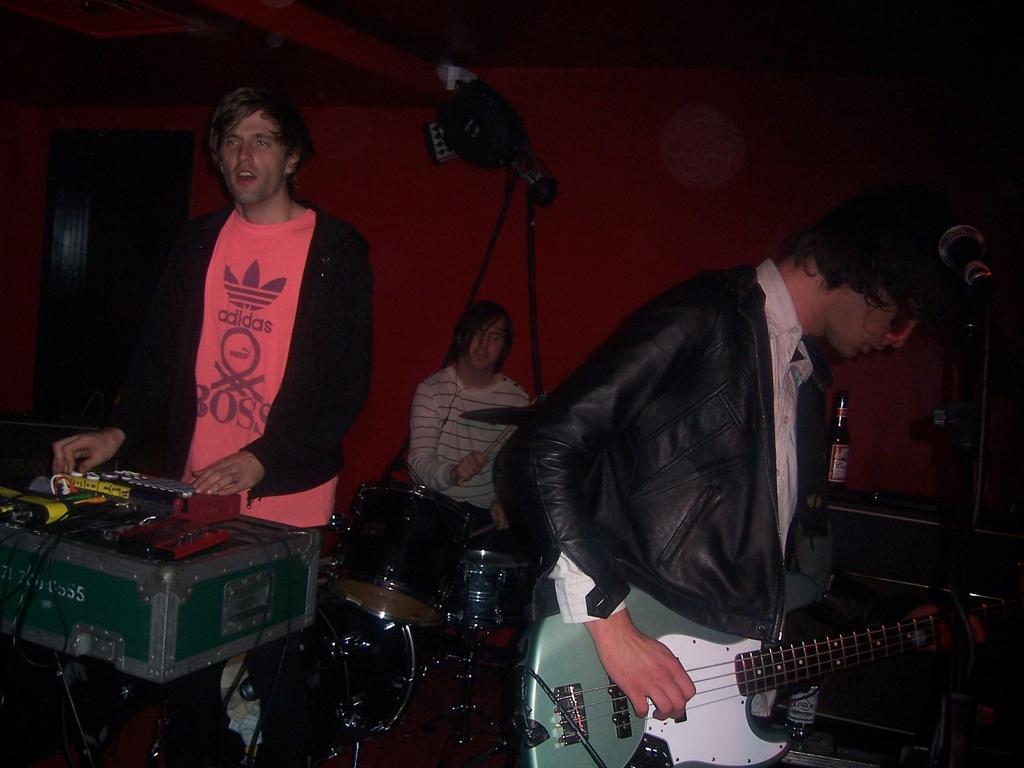How would you summarize this image in a sentence or two? In this image there are three persons playing a musical instruments and at the right side of the image a person playing a guitar and at the left side of the image a person playing a musical instrument and at the middle of the image a person beating the drums. 